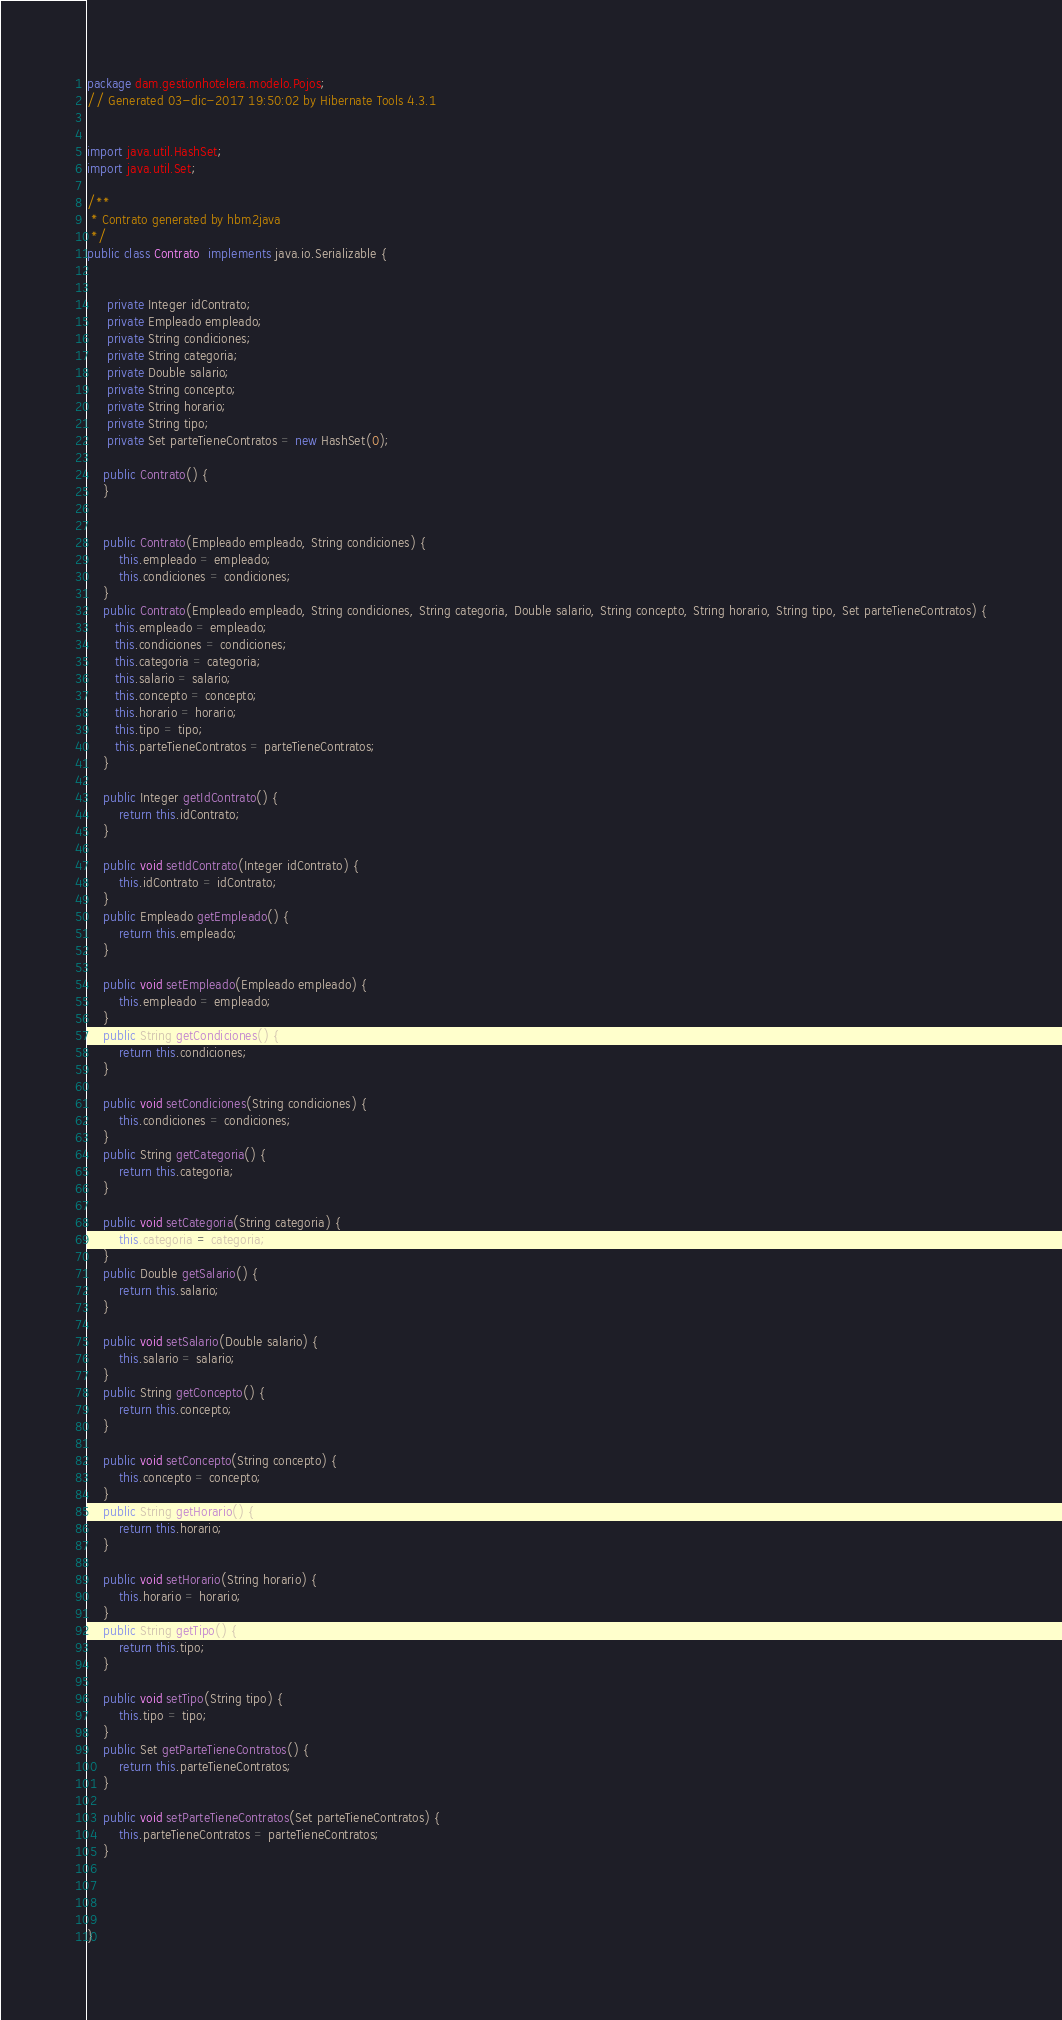Convert code to text. <code><loc_0><loc_0><loc_500><loc_500><_Java_>package dam.gestionhotelera.modelo.Pojos;
// Generated 03-dic-2017 19:50:02 by Hibernate Tools 4.3.1


import java.util.HashSet;
import java.util.Set;

/**
 * Contrato generated by hbm2java
 */
public class Contrato  implements java.io.Serializable {


     private Integer idContrato;
     private Empleado empleado;
     private String condiciones;
     private String categoria;
     private Double salario;
     private String concepto;
     private String horario;
     private String tipo;
     private Set parteTieneContratos = new HashSet(0);

    public Contrato() {
    }

	
    public Contrato(Empleado empleado, String condiciones) {
        this.empleado = empleado;
        this.condiciones = condiciones;
    }
    public Contrato(Empleado empleado, String condiciones, String categoria, Double salario, String concepto, String horario, String tipo, Set parteTieneContratos) {
       this.empleado = empleado;
       this.condiciones = condiciones;
       this.categoria = categoria;
       this.salario = salario;
       this.concepto = concepto;
       this.horario = horario;
       this.tipo = tipo;
       this.parteTieneContratos = parteTieneContratos;
    }
   
    public Integer getIdContrato() {
        return this.idContrato;
    }
    
    public void setIdContrato(Integer idContrato) {
        this.idContrato = idContrato;
    }
    public Empleado getEmpleado() {
        return this.empleado;
    }
    
    public void setEmpleado(Empleado empleado) {
        this.empleado = empleado;
    }
    public String getCondiciones() {
        return this.condiciones;
    }
    
    public void setCondiciones(String condiciones) {
        this.condiciones = condiciones;
    }
    public String getCategoria() {
        return this.categoria;
    }
    
    public void setCategoria(String categoria) {
        this.categoria = categoria;
    }
    public Double getSalario() {
        return this.salario;
    }
    
    public void setSalario(Double salario) {
        this.salario = salario;
    }
    public String getConcepto() {
        return this.concepto;
    }
    
    public void setConcepto(String concepto) {
        this.concepto = concepto;
    }
    public String getHorario() {
        return this.horario;
    }
    
    public void setHorario(String horario) {
        this.horario = horario;
    }
    public String getTipo() {
        return this.tipo;
    }
    
    public void setTipo(String tipo) {
        this.tipo = tipo;
    }
    public Set getParteTieneContratos() {
        return this.parteTieneContratos;
    }
    
    public void setParteTieneContratos(Set parteTieneContratos) {
        this.parteTieneContratos = parteTieneContratos;
    }




}


</code> 